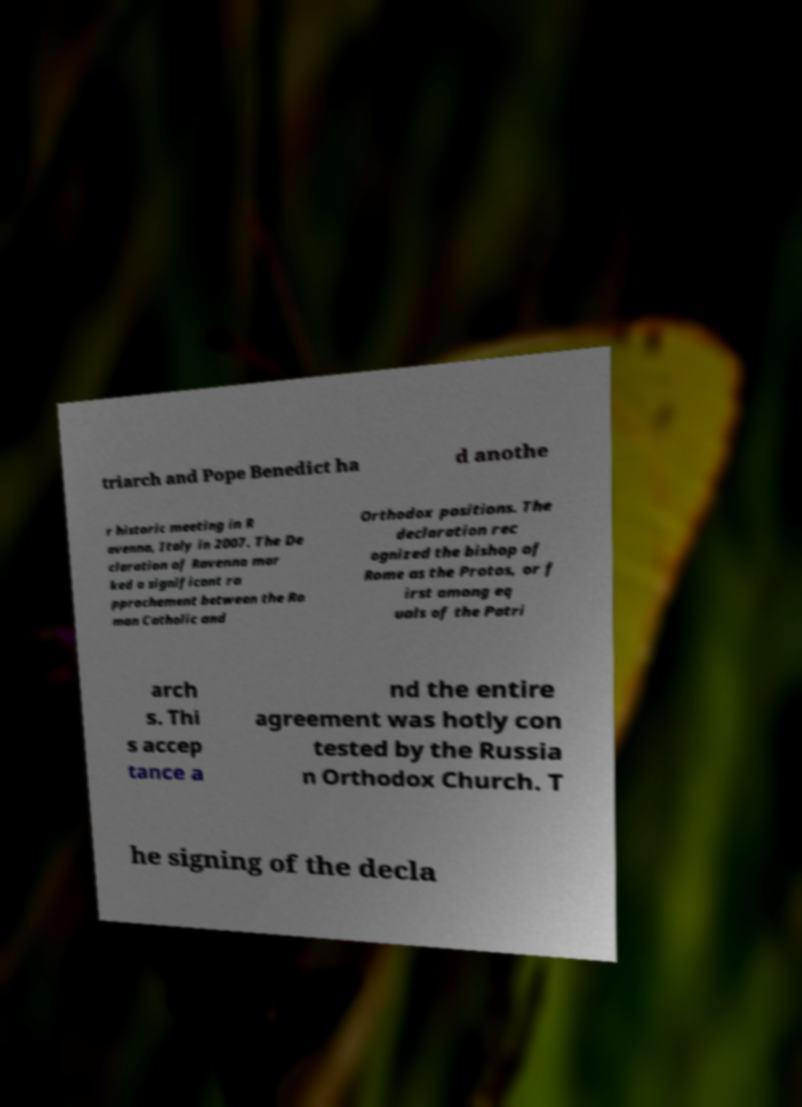Could you assist in decoding the text presented in this image and type it out clearly? triarch and Pope Benedict ha d anothe r historic meeting in R avenna, Italy in 2007. The De claration of Ravenna mar ked a significant ra pprochement between the Ro man Catholic and Orthodox positions. The declaration rec ognized the bishop of Rome as the Protos, or f irst among eq uals of the Patri arch s. Thi s accep tance a nd the entire agreement was hotly con tested by the Russia n Orthodox Church. T he signing of the decla 